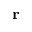Convert formula to latex. <formula><loc_0><loc_0><loc_500><loc_500>{ \Delta r }</formula> 